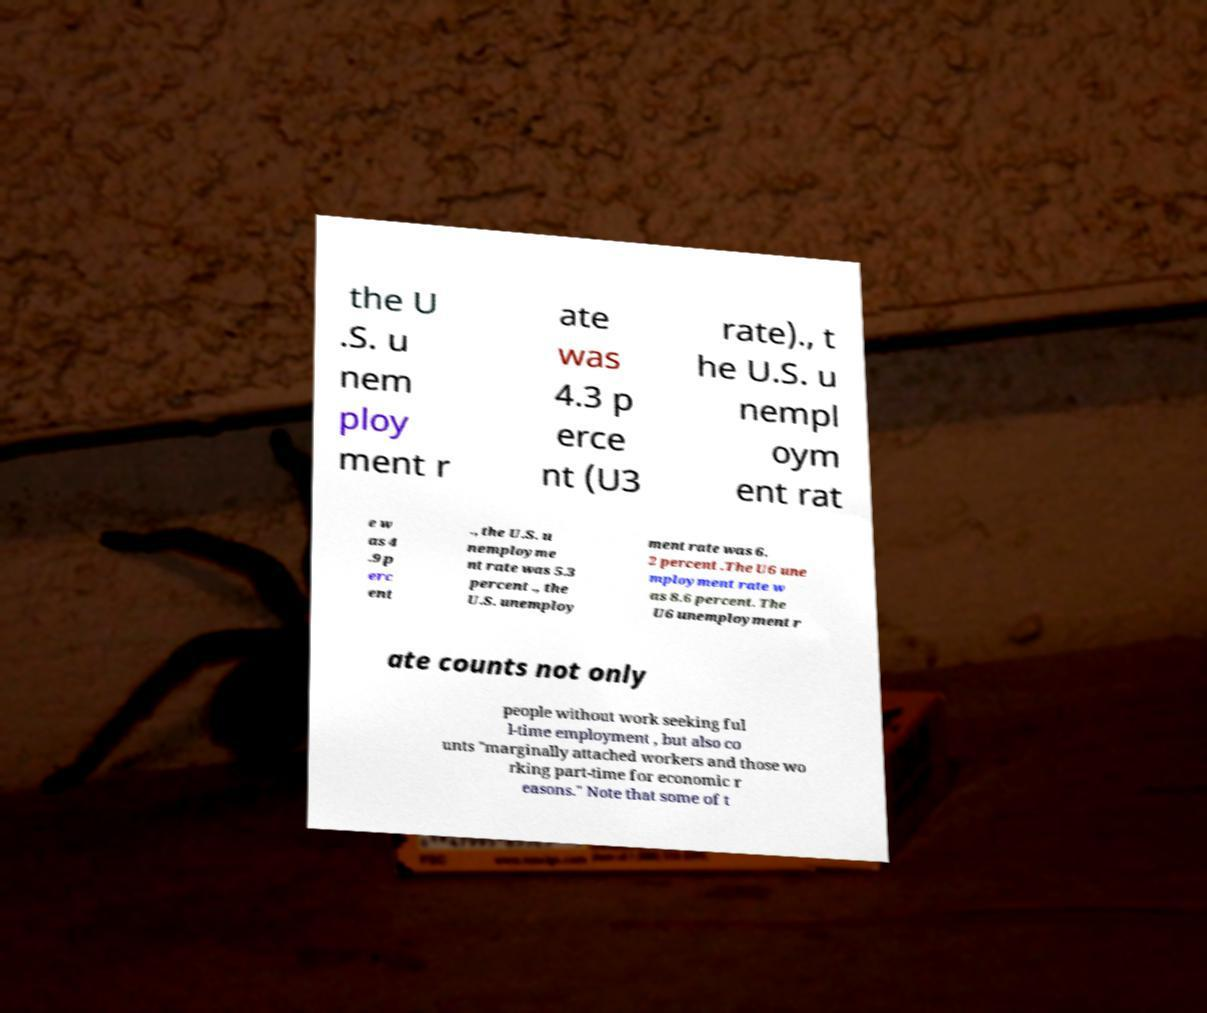What messages or text are displayed in this image? I need them in a readable, typed format. the U .S. u nem ploy ment r ate was 4.3 p erce nt (U3 rate)., t he U.S. u nempl oym ent rat e w as 4 .9 p erc ent ., the U.S. u nemployme nt rate was 5.3 percent ., the U.S. unemploy ment rate was 6. 2 percent .The U6 une mployment rate w as 8.6 percent. The U6 unemployment r ate counts not only people without work seeking ful l-time employment , but also co unts "marginally attached workers and those wo rking part-time for economic r easons." Note that some of t 